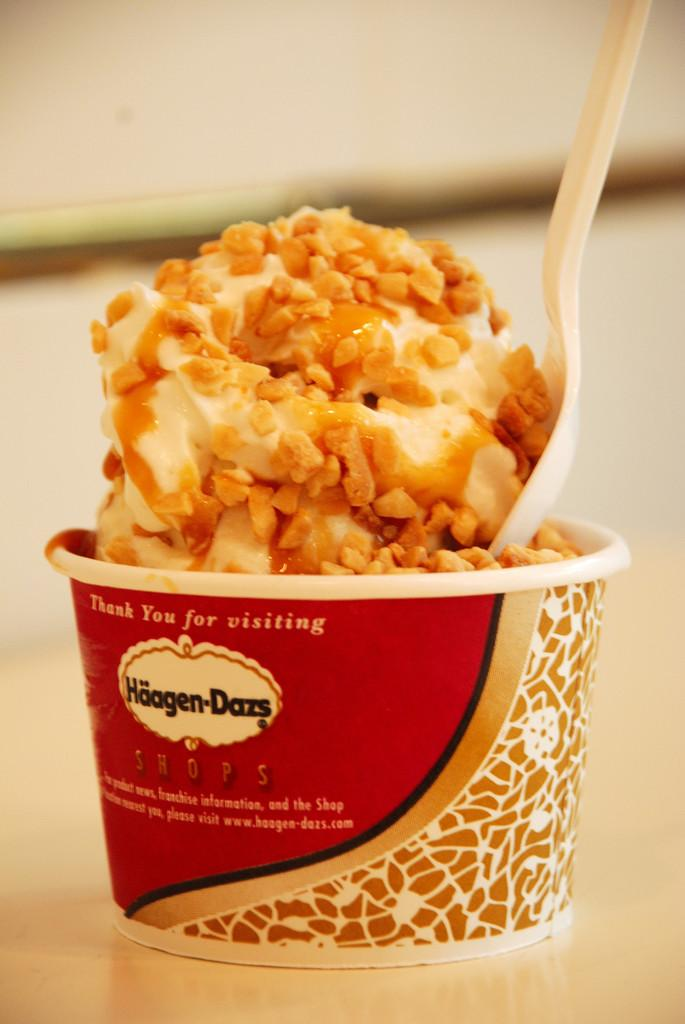What is in the cup that is visible in the image? The cup contains shaving cream and other food items. What utensil is present in the image? There is a white spoon in the image. Where is the cup placed in the image? The cup is placed on a surface. Can you describe the background of the image? The background of the image is blurred. What holiday is being celebrated in the image? There is no indication of a holiday being celebrated in the image. What show is being performed in the image? There is no show or performance taking place in the image. 